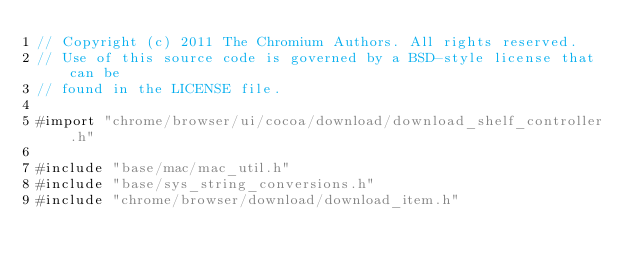Convert code to text. <code><loc_0><loc_0><loc_500><loc_500><_ObjectiveC_>// Copyright (c) 2011 The Chromium Authors. All rights reserved.
// Use of this source code is governed by a BSD-style license that can be
// found in the LICENSE file.

#import "chrome/browser/ui/cocoa/download/download_shelf_controller.h"

#include "base/mac/mac_util.h"
#include "base/sys_string_conversions.h"
#include "chrome/browser/download/download_item.h"</code> 